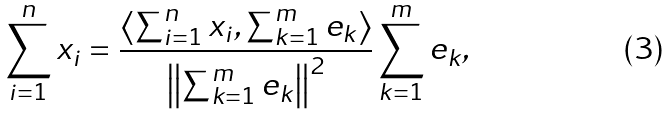<formula> <loc_0><loc_0><loc_500><loc_500>\sum _ { i = 1 } ^ { n } x _ { i } = \frac { \left \langle \sum _ { i = 1 } ^ { n } x _ { i } , \sum _ { k = 1 } ^ { m } e _ { k } \right \rangle } { \left \| \sum _ { k = 1 } ^ { m } e _ { k } \right \| ^ { 2 } } \sum _ { k = 1 } ^ { m } e _ { k } ,</formula> 